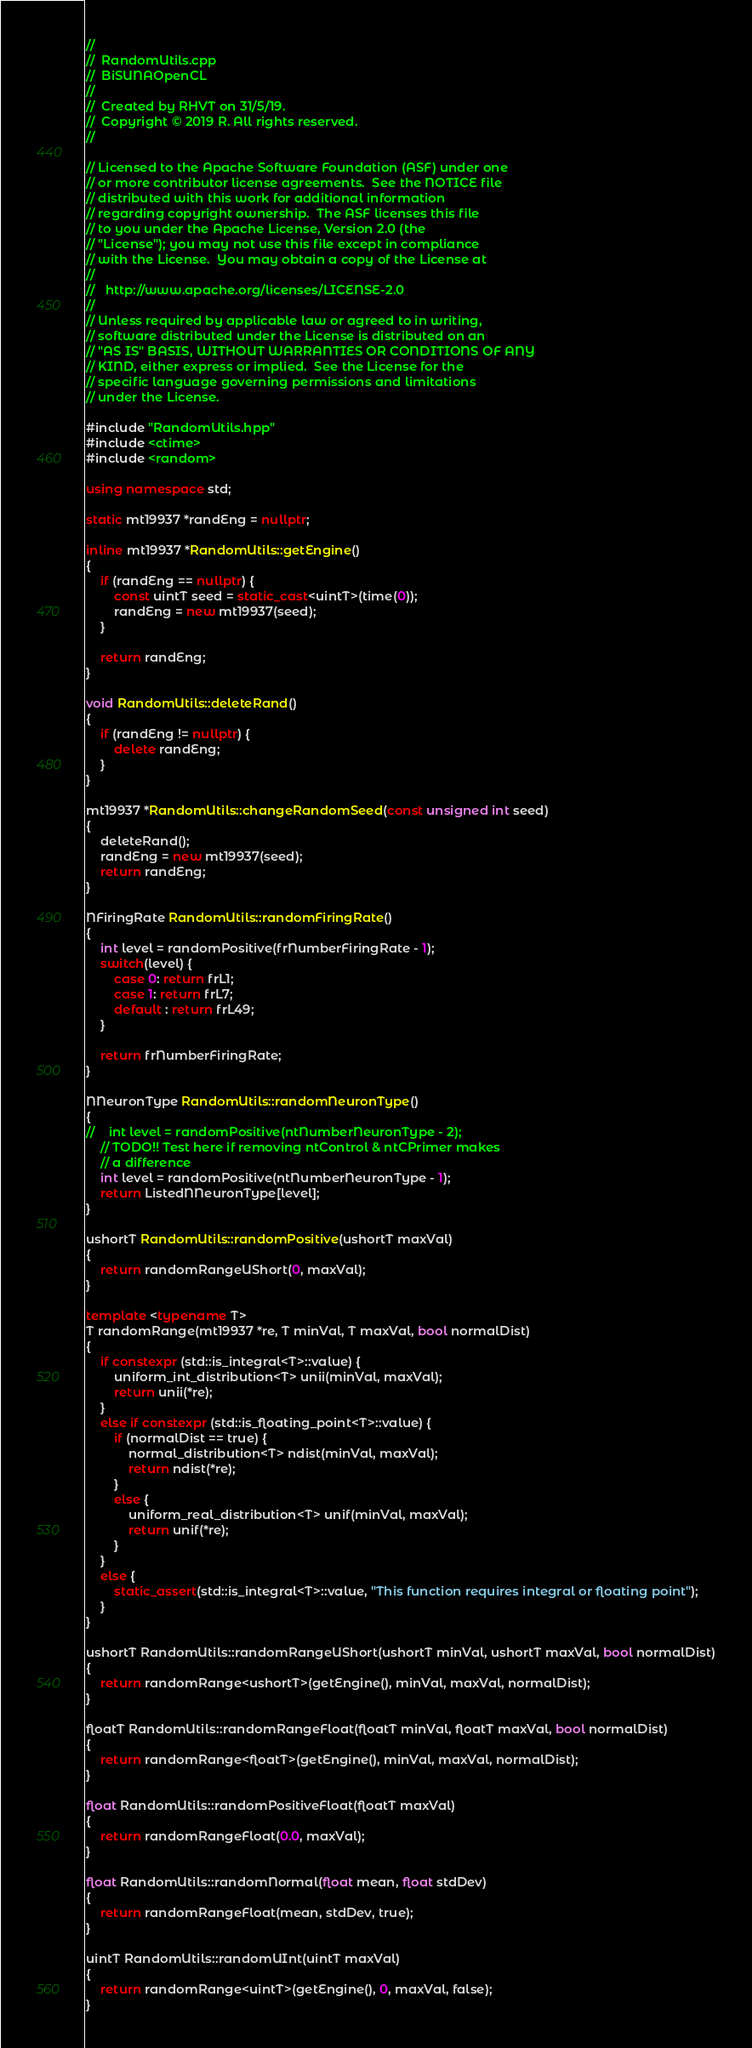<code> <loc_0><loc_0><loc_500><loc_500><_C++_>//
//  RandomUtils.cpp
//  BiSUNAOpenCL
//
//  Created by RHVT on 31/5/19.
//  Copyright © 2019 R. All rights reserved.
//

// Licensed to the Apache Software Foundation (ASF) under one
// or more contributor license agreements.  See the NOTICE file
// distributed with this work for additional information
// regarding copyright ownership.  The ASF licenses this file
// to you under the Apache License, Version 2.0 (the
// "License"); you may not use this file except in compliance
// with the License.  You may obtain a copy of the License at
//
//   http://www.apache.org/licenses/LICENSE-2.0
//
// Unless required by applicable law or agreed to in writing,
// software distributed under the License is distributed on an
// "AS IS" BASIS, WITHOUT WARRANTIES OR CONDITIONS OF ANY
// KIND, either express or implied.  See the License for the
// specific language governing permissions and limitations
// under the License.

#include "RandomUtils.hpp"
#include <ctime>
#include <random>

using namespace std;

static mt19937 *randEng = nullptr;

inline mt19937 *RandomUtils::getEngine()
{
    if (randEng == nullptr) {
        const uintT seed = static_cast<uintT>(time(0));
        randEng = new mt19937(seed);
    }
    
    return randEng;
}

void RandomUtils::deleteRand()
{
    if (randEng != nullptr) {
        delete randEng;
    }
}

mt19937 *RandomUtils::changeRandomSeed(const unsigned int seed)
{
    deleteRand();
    randEng = new mt19937(seed);
    return randEng;
}

NFiringRate RandomUtils::randomFiringRate()
{
    int level = randomPositive(frNumberFiringRate - 1);
    switch(level) {
        case 0: return frL1;
        case 1: return frL7;
        default : return frL49;
    }
    
    return frNumberFiringRate;
}

NNeuronType RandomUtils::randomNeuronType()
{
//    int level = randomPositive(ntNumberNeuronType - 2);
    // TODO!! Test here if removing ntControl & ntCPrimer makes
    // a difference
    int level = randomPositive(ntNumberNeuronType - 1);
    return ListedNNeuronType[level];
}

ushortT RandomUtils::randomPositive(ushortT maxVal)
{
    return randomRangeUShort(0, maxVal);
}

template <typename T>
T randomRange(mt19937 *re, T minVal, T maxVal, bool normalDist)
{
    if constexpr (std::is_integral<T>::value) {
        uniform_int_distribution<T> unii(minVal, maxVal);
        return unii(*re);
    }
    else if constexpr (std::is_floating_point<T>::value) {
        if (normalDist == true) {
            normal_distribution<T> ndist(minVal, maxVal);
            return ndist(*re);
        }
        else {
            uniform_real_distribution<T> unif(minVal, maxVal);
            return unif(*re);
        }
    }
    else {
        static_assert(std::is_integral<T>::value, "This function requires integral or floating point");
    }
}

ushortT RandomUtils::randomRangeUShort(ushortT minVal, ushortT maxVal, bool normalDist)
{
    return randomRange<ushortT>(getEngine(), minVal, maxVal, normalDist);
}

floatT RandomUtils::randomRangeFloat(floatT minVal, floatT maxVal, bool normalDist)
{
    return randomRange<floatT>(getEngine(), minVal, maxVal, normalDist);
}

float RandomUtils::randomPositiveFloat(floatT maxVal)
{
    return randomRangeFloat(0.0, maxVal);
}

float RandomUtils::randomNormal(float mean, float stdDev)
{
    return randomRangeFloat(mean, stdDev, true);
}

uintT RandomUtils::randomUInt(uintT maxVal)
{
    return randomRange<uintT>(getEngine(), 0, maxVal, false);
}
</code> 